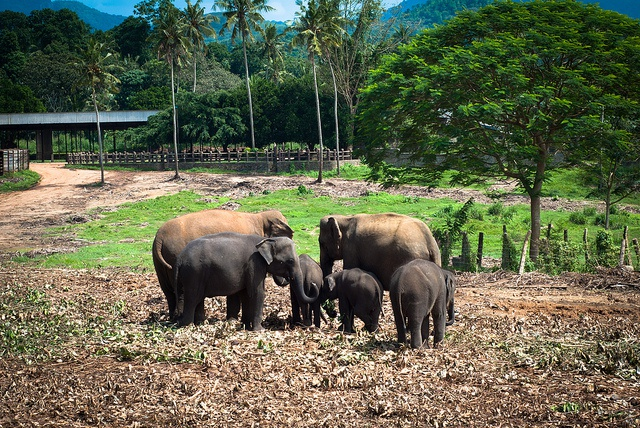Describe the objects in this image and their specific colors. I can see elephant in blue, black, gray, and darkgray tones, elephant in blue, black, tan, and gray tones, elephant in blue, black, gray, and darkgray tones, elephant in blue, black, and tan tones, and elephant in blue, black, gray, and darkgray tones in this image. 